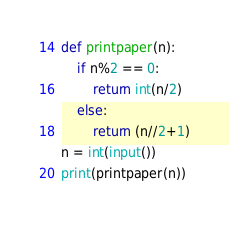<code> <loc_0><loc_0><loc_500><loc_500><_Python_>def printpaper(n):
    if n%2 == 0:
        return int(n/2)
    else:
        return (n//2+1)
n = int(input())
print(printpaper(n))</code> 